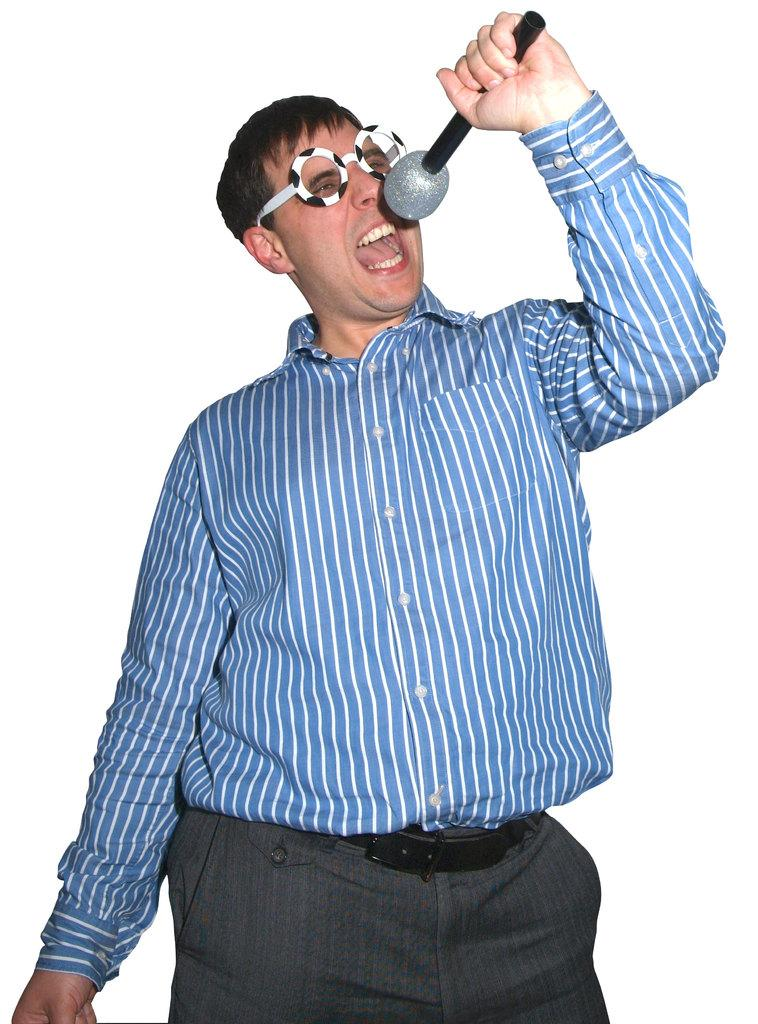Who is the main subject in the image? There is a man in the image. What is the man holding in his hand? The man is holding a microphone in his hand. What is the man doing in the image? The man is singing. What type of eyewear is the man wearing? The man is wearing fancy spectacles. What type of locket is hanging around the man's neck in the image? There is no locket visible around the man's neck in the image. 